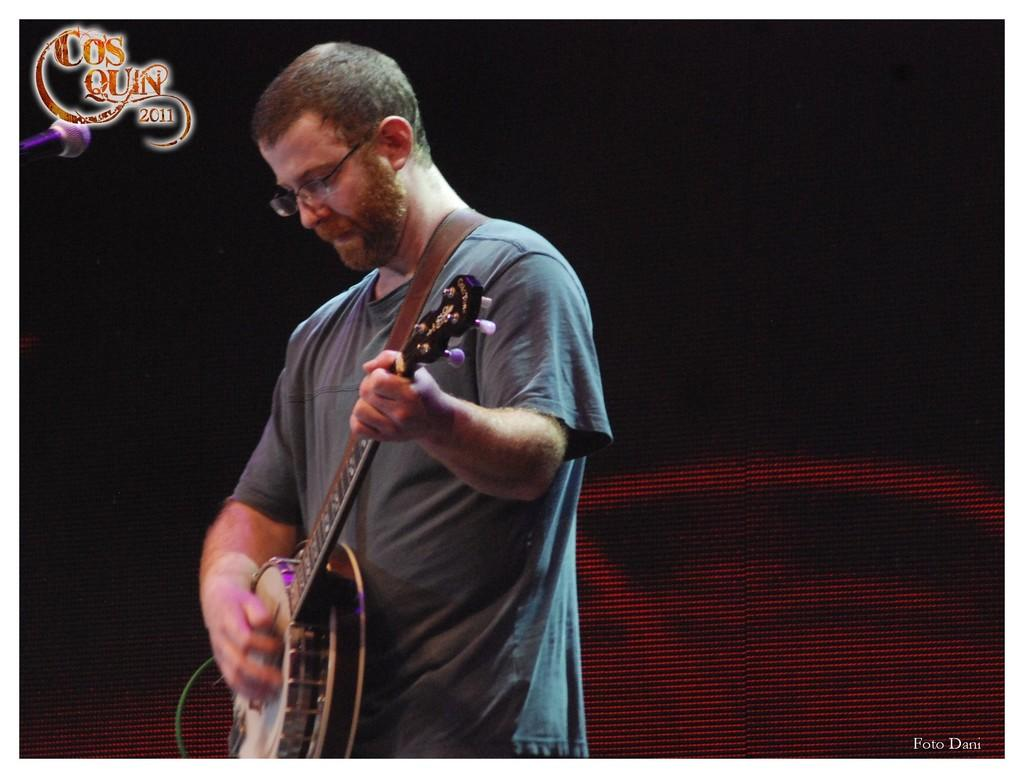Who is the main subject in the image? There is a man in the image. What is the man doing in the image? The man is standing and playing a guitar. What can be seen in the background of the image? There is a screen in the background of the image. Where is the library located in the image? There is no library present in the image. What type of cork is used to hold the guitar strings in place in the image? There is no cork mentioned or visible in the image; the guitar strings are held in place by the guitar's tuning pegs. 